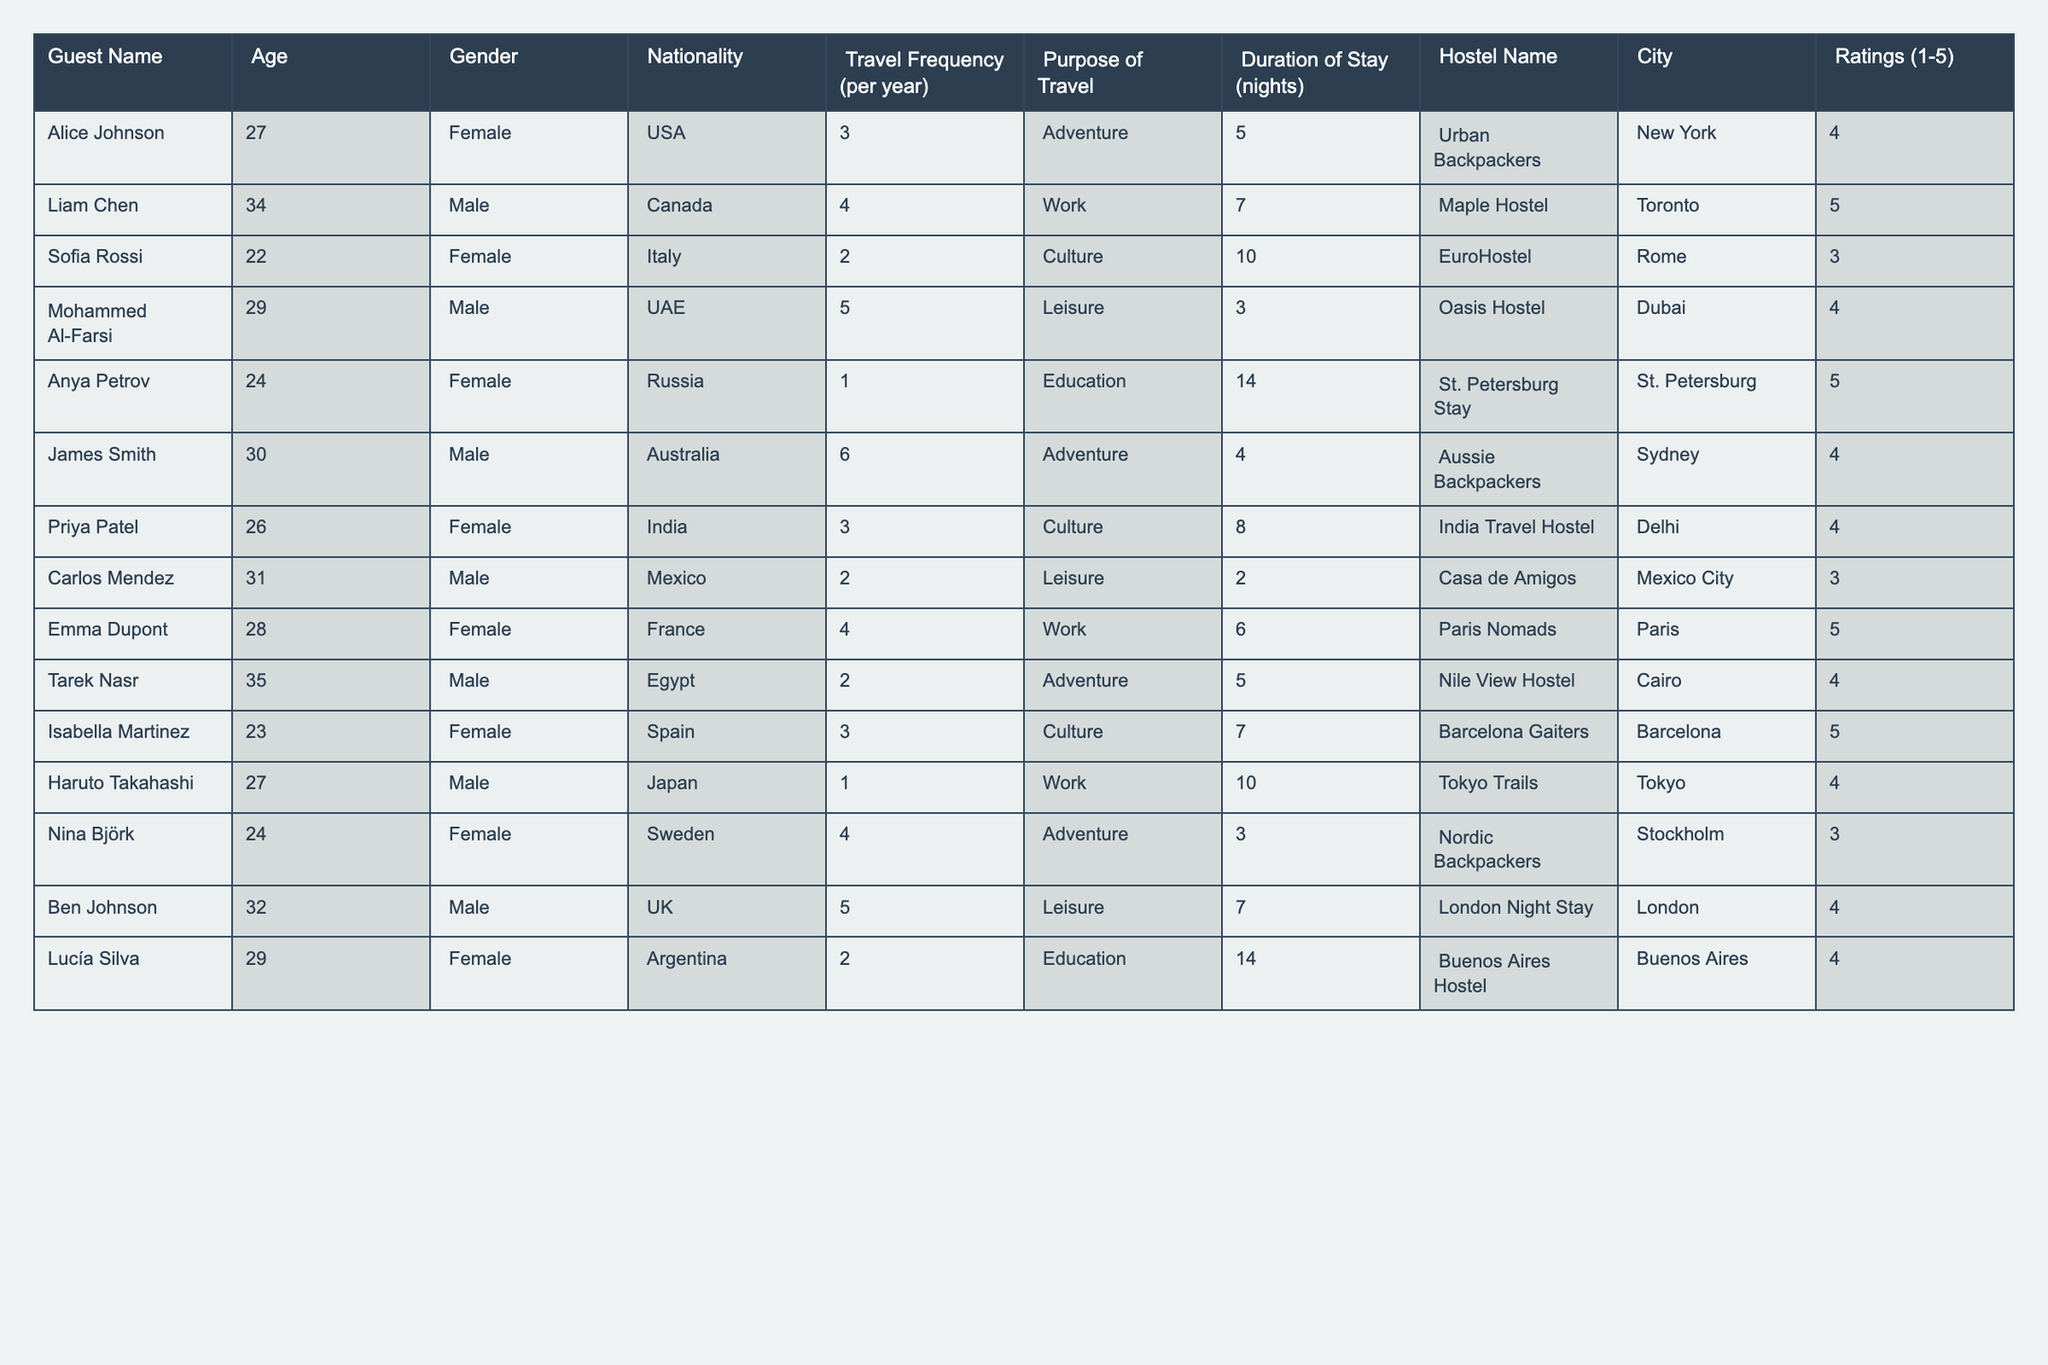What is the average age of the guests? To find the average age, we sum the ages of all guests: 27 + 34 + 22 + 29 + 24 + 30 + 26 + 31 + 28 + 35 + 23 + 27 + 24 + 32 + 29 = 438. There are 15 guests, so we divide 438 by 15, giving us 29.2.
Answer: 29.2 How many guests are from the USA? Looking at the Nationality column, we find that only one guest (Alice Johnson) is from the USA.
Answer: 1 What is the highest rating given to a hostel? By reviewing the Ratings column, the highest rating is 5, given to guests staying at Maple Hostel, Anya Petrov's hostel, Emma Dupont's hostel, and Isabella Martinez's hostel.
Answer: 5 Which guests have a purpose of travel listed as "Work"? The guests with a purpose of travel as "Work" are Liam Chen, Emma Dupont, and Haruto Takahashi.
Answer: Liam Chen, Emma Dupont, Haruto Takahashi What is the total duration of stay for guests from Italy? The guest from Italy is Sofia Rossi, who stayed for 10 nights. Therefore, the total duration of stay for guests from Italy is 10 nights.
Answer: 10 nights How many guests stayed longer than 7 nights? By reviewing the Duration of Stay column, the guests who stayed longer than 7 nights are Liam Chen (7 nights), Anya Petrov (14 nights), Emma Dupont (6 nights), and Lucía Silva (14 nights). This is a total of 6 nights for those who meet the criteria.
Answer: 4 Is there any guest who has traveled more than 6 times in a year? Checking the Travel Frequency column, we see that James Smith and Mohammed Al-Farsi traveled more than 6 times a year with frequency of 6 and 5 respectively. Thus, the answer is Yes.
Answer: Yes What is the average travel frequency for guests from Canada? The only guest from Canada is Liam Chen, who travels 4 times a year. Thus the average for Canadian guests is 4.
Answer: 4 What percentage of guests stayed at least 10 nights? To find the percentage, we note that Anya Petrov (14), Sofia Rossi (10), and Haruto Takahashi (10) stayed at least 10 nights. This means 3 out of 15 guests. Therefore, the percentage is (3/15) * 100 = 20%.
Answer: 20% Which gender has more guests listed? By counting the Gender column, we find that there are 7 female guests (Alice, Sofia, Anya, Priya, Isabella, Nina, Lucía) and 8 male guests (Liam, Mohammed, James, Tarek, Haruto, Ben). Thus, more guests are male.
Answer: Male How many guests have an adventure purpose of travel? Looking at the Purpose of Travel column, the guests with "Adventure" as their purpose are Alice Johnson, James Smith, and Tarek Nasr. Therefore, there are 3 guests.
Answer: 3 